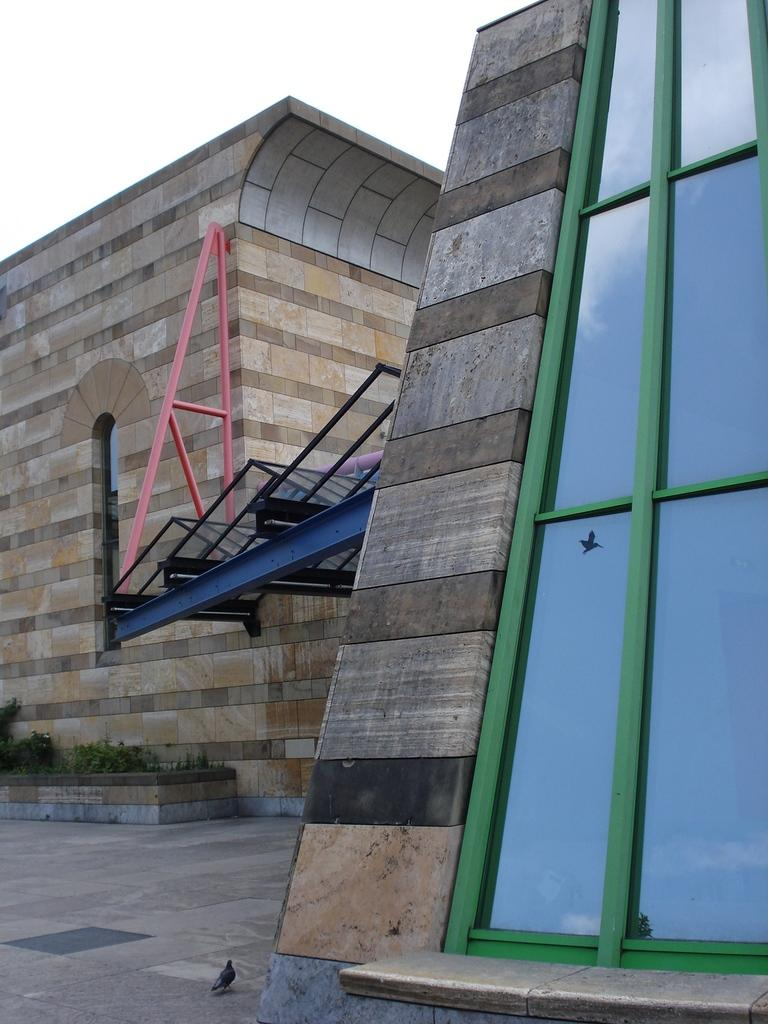What is the main structure in the center of the image? There is a building in the center of the image. What can be seen at the bottom of the image? A pigeon and plants are present at the bottom of the image. What material is used at the bottom of the image? Glass is present at the bottom of the image. What is visible at the top of the image? The sky is visible at the top of the image. Where is the camera located in the image? There is no camera present in the image. What type of shoe is visible on the pigeon in the image? There is no shoe present on the pigeon in the image. 